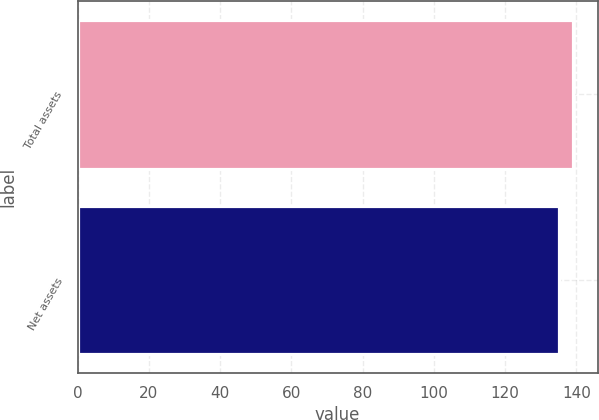Convert chart. <chart><loc_0><loc_0><loc_500><loc_500><bar_chart><fcel>Total assets<fcel>Net assets<nl><fcel>139<fcel>135<nl></chart> 